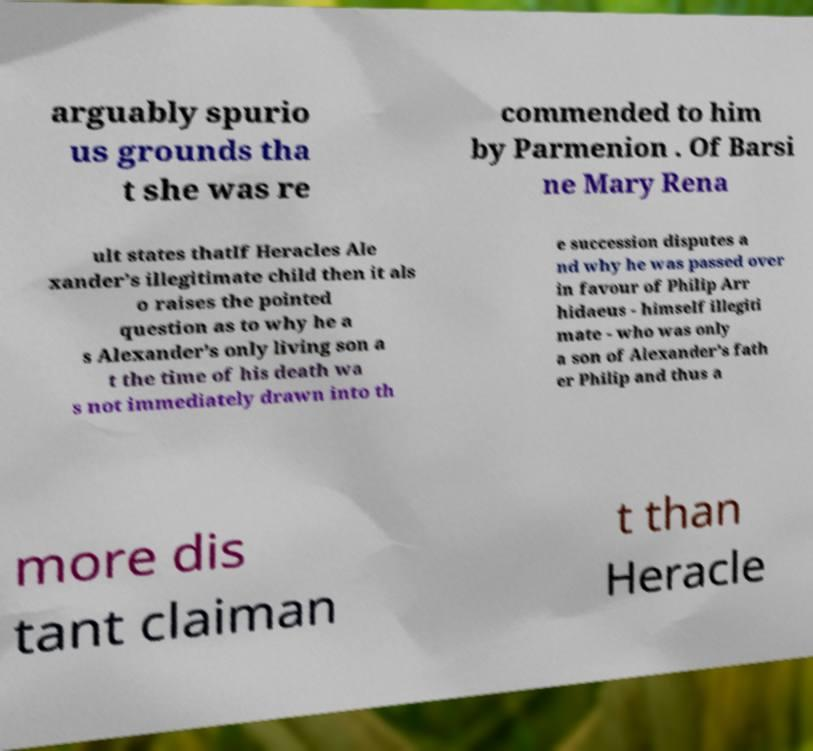Please identify and transcribe the text found in this image. arguably spurio us grounds tha t she was re commended to him by Parmenion . Of Barsi ne Mary Rena ult states thatIf Heracles Ale xander’s illegitimate child then it als o raises the pointed question as to why he a s Alexander’s only living son a t the time of his death wa s not immediately drawn into th e succession disputes a nd why he was passed over in favour of Philip Arr hidaeus - himself illegiti mate - who was only a son of Alexander’s fath er Philip and thus a more dis tant claiman t than Heracle 